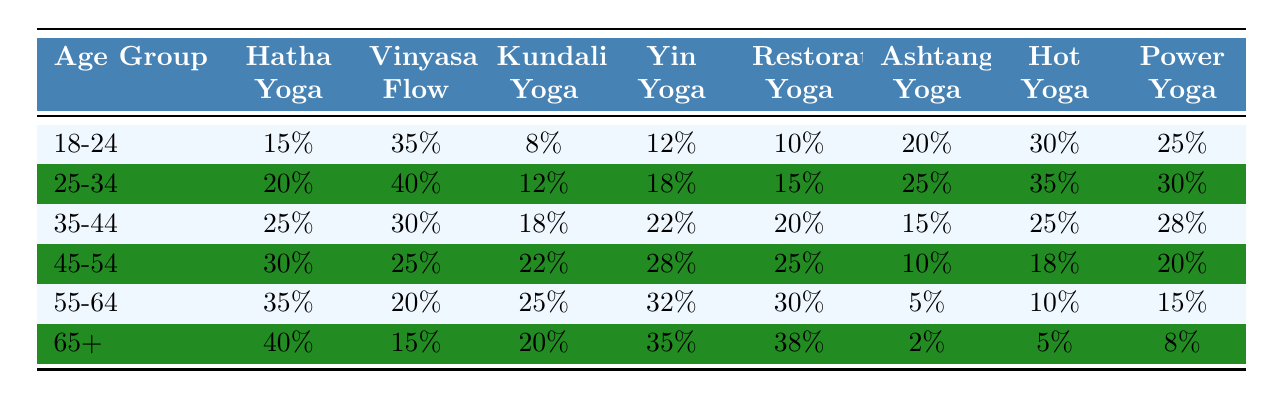What is the most popular yoga style among the 25-34 age group? Looking at the table, Vinyasa Flow has the highest percentage at 40% for the 25-34 age group.
Answer: Vinyasa Flow Which yoga style is least popular among the 65+ age group? Analyzing the data for the 65+ age group, Ashtanga Yoga has the lowest percentage at 2%.
Answer: Ashtanga Yoga How much more popular is Hot Yoga compared to Restorative Yoga in the 35-44 age group? For the 35-44 age group, Hot Yoga is at 25% and Restorative Yoga is at 20%. The difference is 25% - 20% = 5%.
Answer: 5% What percentage of the 55-64 age group practices Ashtanga Yoga? The table shows that 5% of the 55-64 age group practices Ashtanga Yoga.
Answer: 5% Which age group has the highest preference for Hatha Yoga? Examining the table, the 65+ age group has the highest preference for Hatha Yoga at 40%.
Answer: 65+ What is the average popularity of Power Yoga across all age groups? The popularity data for Power Yoga is 25%, 30%, 28%, 20%, 15%, and 8%. The average is (25 + 30 + 28 + 20 + 15 + 8) / 6 = 126 / 6 = 21%.
Answer: 21% Is Yin Yoga more popular among the 45-54 age group than among the 55-64 age group? For the 45-54 age group, Yin Yoga is at 28%, while for the 55-64 age group, it is at 32%. Therefore, Yin Yoga is less popular among the 45-54 age group.
Answer: No What is the combined popularity of Hatha Yoga and Power Yoga in the 18-24 age group? The popularity of Hatha Yoga in the 18-24 age group is 15%, and Power Yoga is 25%. The combined popularity is 15% + 25% = 40%.
Answer: 40% Which yoga style remains consistently above 30% in popularity from the 18-24 age group to the 65+ age group? Looking at the data, only Hatha Yoga and Restorative Yoga show consistency above 30% across age groups starting from the 55-64 age group, while Hatha Yoga consistently sits above 30% across all age groups.
Answer: Hatha Yoga In the 45-54 age group, how does the popularity of Vinyasa Flow compare to that of Hot Yoga? For the 45-54 age group, Vinyasa Flow is at 25%, and Hot Yoga is at 18%. Vinyasa Flow is more popular than Hot Yoga by 7%.
Answer: Vinyasa Flow is more popular by 7% 